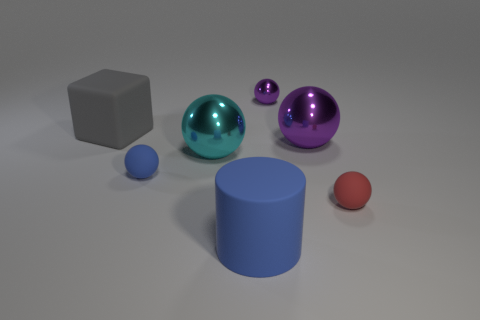There is a large rubber object in front of the red ball; is it the same color as the tiny matte sphere left of the cyan object?
Ensure brevity in your answer.  Yes. What is the shape of the purple object that is behind the big metal sphere behind the cyan ball?
Your answer should be very brief. Sphere. Is there a metallic object that has the same size as the cylinder?
Offer a very short reply. Yes. What number of small red matte objects are the same shape as the large cyan metallic object?
Offer a very short reply. 1. Are there the same number of tiny red objects that are in front of the large blue matte object and small blue matte things on the right side of the gray object?
Keep it short and to the point. No. Are there any cyan spheres?
Your answer should be compact. Yes. There is a rubber sphere left of the blue object that is in front of the small rubber thing on the left side of the matte cylinder; what size is it?
Provide a short and direct response. Small. There is a blue matte thing that is the same size as the matte block; what shape is it?
Give a very brief answer. Cylinder. How many things are large things that are right of the gray block or big blue objects?
Give a very brief answer. 3. There is a big sphere that is left of the matte thing that is in front of the tiny red rubber sphere; are there any big cylinders on the right side of it?
Make the answer very short. Yes. 